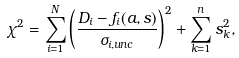<formula> <loc_0><loc_0><loc_500><loc_500>\chi ^ { 2 } = \sum _ { i = 1 } ^ { N } \left ( \frac { D _ { i } - f _ { i } ( a , s ) } { \sigma _ { i , u n c } } \right ) ^ { 2 } + \sum _ { k = 1 } ^ { n } s _ { k } ^ { 2 } ,</formula> 